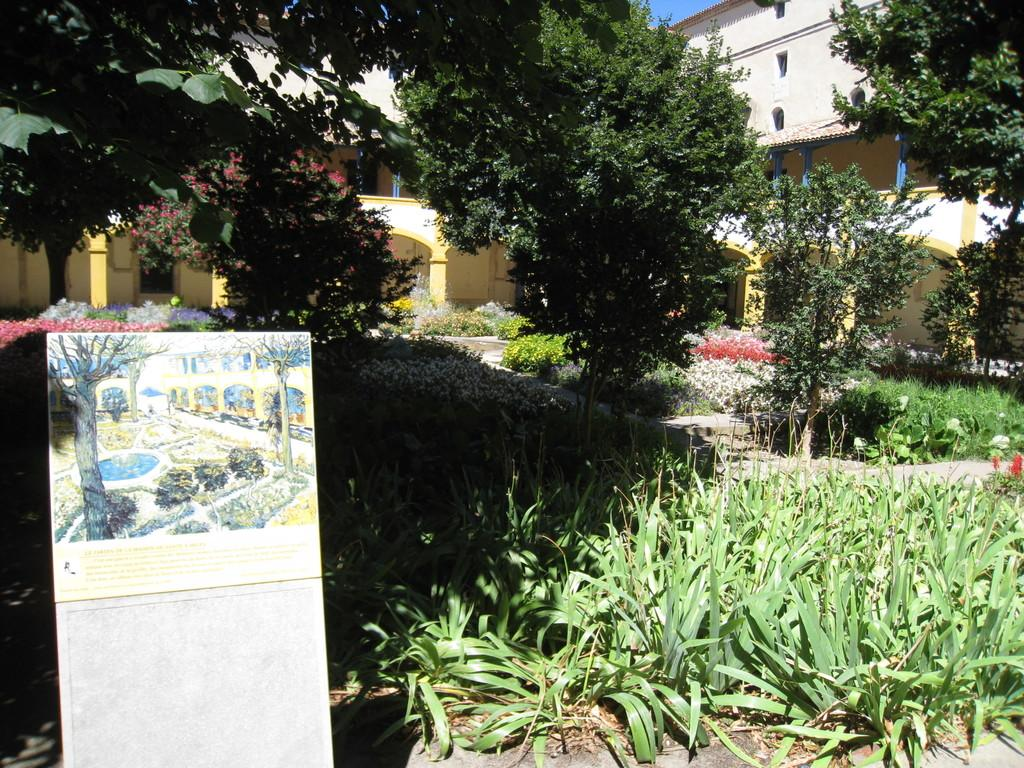What is on the wall on the left side of the image? There is a painting on the wall on the left side of the image. What does the painting depict? The painting depicts plants and trees. Are there any plants or trees visible in the image? Yes, there are plants and trees in the image. What can be seen in the background of the image? There is a building in the background of the image. What reward does the girl receive from her aunt in the image? There is no girl or aunt present in the image, so there is no reward being given. 